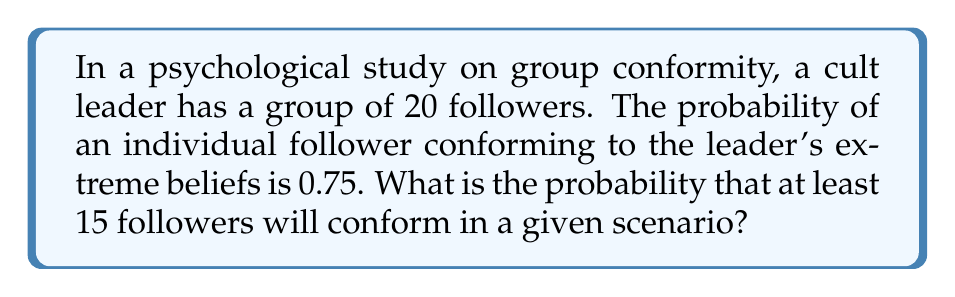Can you answer this question? To solve this problem, we'll use the binomial probability distribution, as we're dealing with a fixed number of independent trials (followers) with two possible outcomes (conform or not conform).

Let's define our variables:
$n = 20$ (total number of followers)
$p = 0.75$ (probability of an individual conforming)
$X$ = number of followers who conform

We want to find $P(X \geq 15)$

Step 1: Calculate the probability of exactly $k$ followers conforming for $k = 15$ to $20$:

$P(X = k) = \binom{n}{k} p^k (1-p)^{n-k}$

Step 2: Sum these probabilities:

$$P(X \geq 15) = \sum_{k=15}^{20} \binom{20}{k} (0.75)^k (0.25)^{20-k}$$

Step 3: Calculate each term:
$P(X = 15) = \binom{20}{15} (0.75)^{15} (0.25)^5 \approx 0.2007$
$P(X = 16) = \binom{20}{16} (0.75)^{16} (0.25)^4 \approx 0.2342$
$P(X = 17) = \binom{20}{17} (0.75)^{17} (0.25)^3 \approx 0.2031$
$P(X = 18) = \binom{20}{18} (0.75)^{18} (0.25)^2 \approx 0.1268$
$P(X = 19) = \binom{20}{19} (0.75)^{19} (0.25)^1 \approx 0.0531$
$P(X = 20) = \binom{20}{20} (0.75)^{20} (0.25)^0 \approx 0.0032$

Step 4: Sum the probabilities:

$P(X \geq 15) = 0.2007 + 0.2342 + 0.2031 + 0.1268 + 0.0531 + 0.0032 \approx 0.8211$
Answer: The probability that at least 15 out of 20 followers will conform is approximately 0.8211 or 82.11%. 